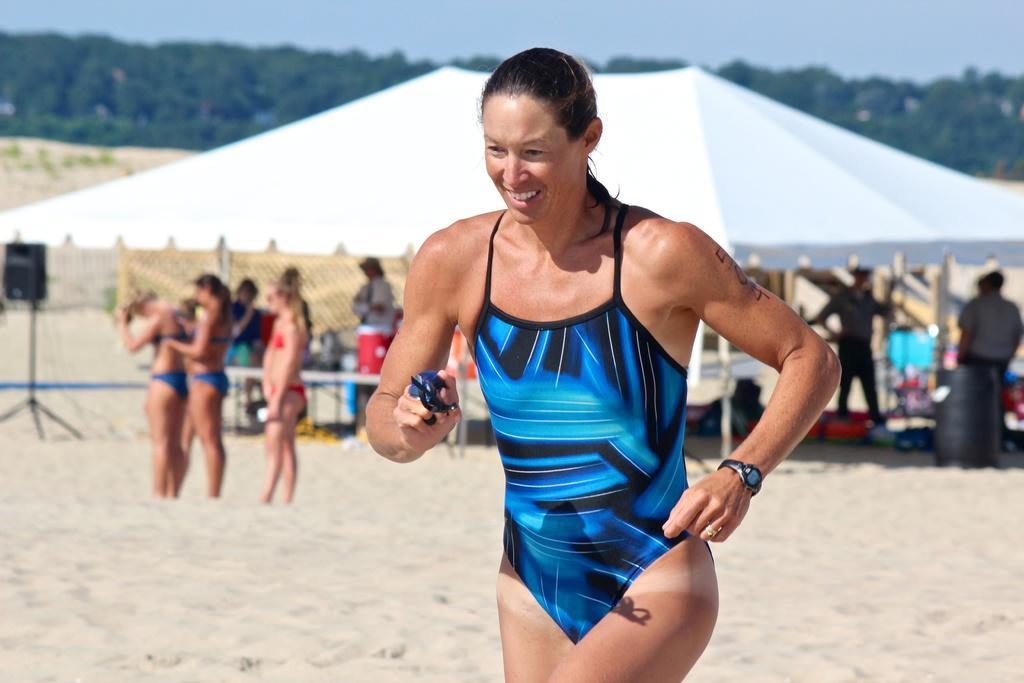Could you give a brief overview of what you see in this image? In the image we can see a woman wearing clothes, wrist watch, finger ring and she is holding an object in her hand. Behind her there are many other people standing and wearing clothes. Here we can see sand, pole tent, trees and a sky. 